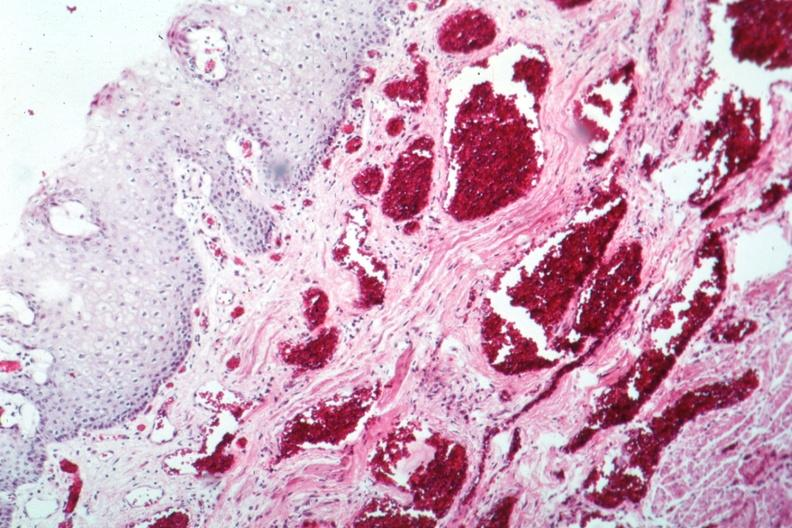s esophagus present?
Answer the question using a single word or phrase. Yes 